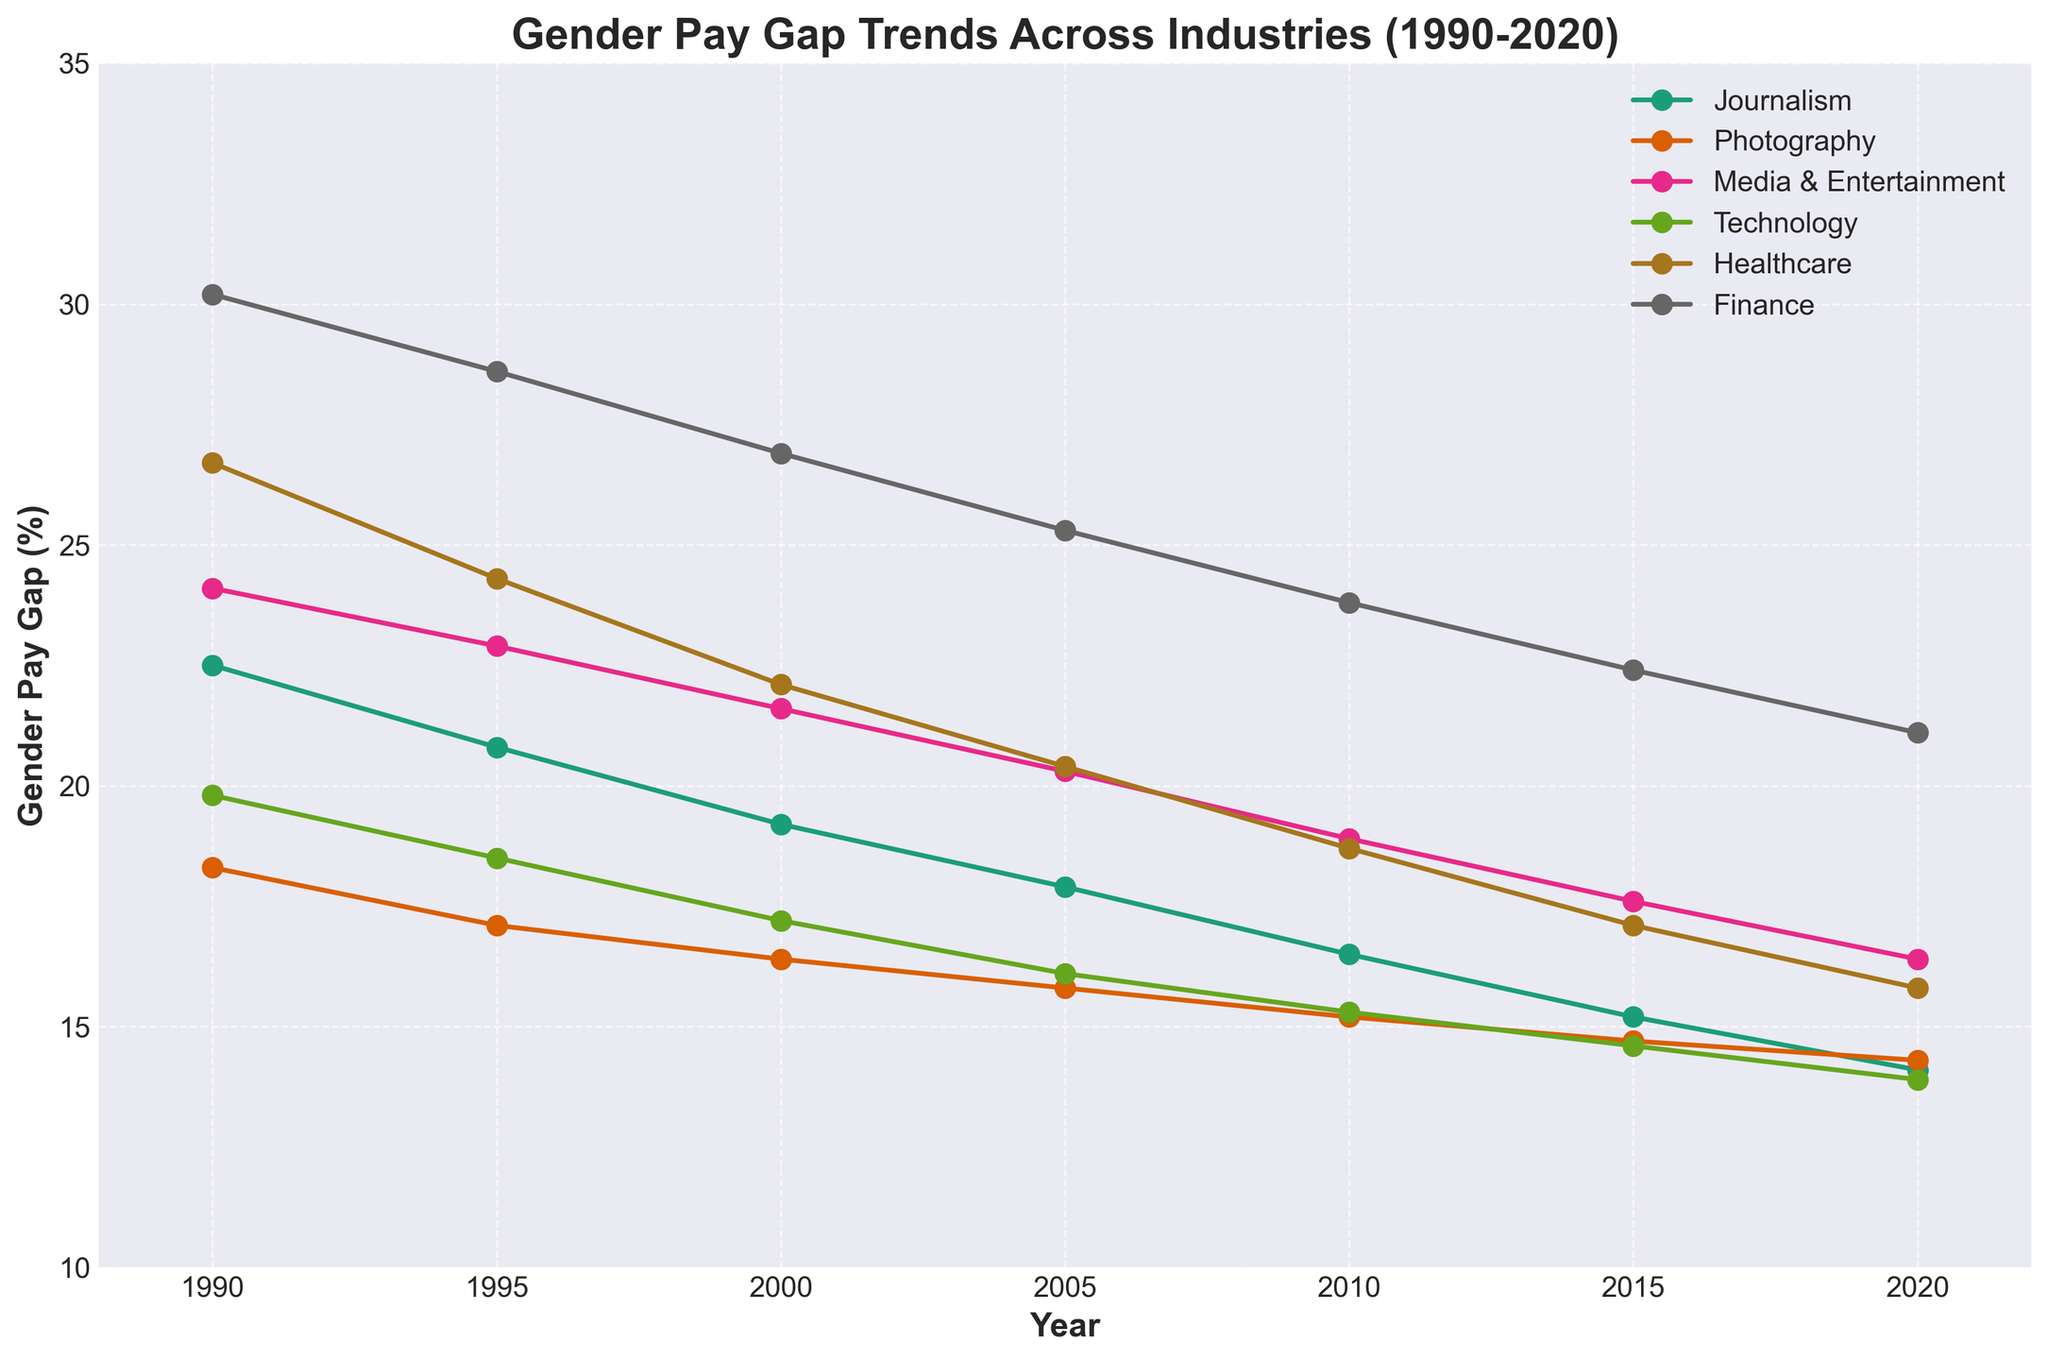Which industry had the highest gender pay gap in 1990? From the figure, the highest line in 1990 corresponds to the Finance industry, as indicated by the data points and the legend.
Answer: Finance What was the general trend of the gender pay gap in the Journalism industry between 1990 and 2020? Observe the line representing the Journalism industry from 1990 to 2020. It starts at a high value and decreases steadily.
Answer: Decreasing Which year had the smallest gender pay gap in the Photography industry? Identify the lowest point on the line corresponding to the Photography industry. From the visual, it's in 2020.
Answer: 2020 By how much did the gender pay gap in Healthcare reduce from 1990 to 2020? Subtract the 2020 value of Healthcare from the 1990 value. The values are 26.7% in 1990 and 15.8% in 2020. Hence, 26.7 - 15.8 = 10.9%.
Answer: 10.9% Which two industries had a similar gender pay gap in 2000? Identify the lines that intersect or are very close in 2000. In 2000, the lines for Journalism and Finance are quite close.
Answer: Journalism and Finance Which industry shows the most consistent decline in the gender pay gap across the observed years? Look for the industry line that shows a uniform decrease from 1990 to 2020. The Journalism industry displays a consistent downward trend.
Answer: Journalism In which year did the Technology industry's gender pay gap fall below 15%? Trace the line representing Technology and find the point where it first goes below 15%. This happens in 2015.
Answer: 2015 How does the gender pay gap in Technology in 2005 compare to that in Finance in the same year? Compare the height of the Technology line with that of the Finance line in 2005. The gender pay gap in Technology is lower than in Finance in 2005.
Answer: Lower What is the average gender pay gap in Media & Entertainment across all observed years? Sum the gender pay gap values for Media & Entertainment from 1990 to 2020 and divide by the number of years (7). The sum is 24.1 + 22.9 + 21.6 + 20.3 + 18.9 + 17.6 + 16.4 = 141.8. The average is 141.8/7 = 20.26%.
Answer: 20.26% Which industry experienced the greatest reduction in the gender pay gap from 1990 to 2020? Calculate the difference in gender pay gap for each industry between 1990 and 2020 and find the maximum. Journalism: 22.5 - 14.1 = 8.4, Photography: 18.3 - 14.3 = 4, Media & Entertainment: 24.1 - 16.4 = 7.7, Technology: 19.8 - 13.9 = 5.9, Healthcare: 26.7 - 15.8 = 10.9, Finance: 30.2 - 21.1 = 9.1. Healthcare has the greatest reduction with 10.9%.
Answer: Healthcare 